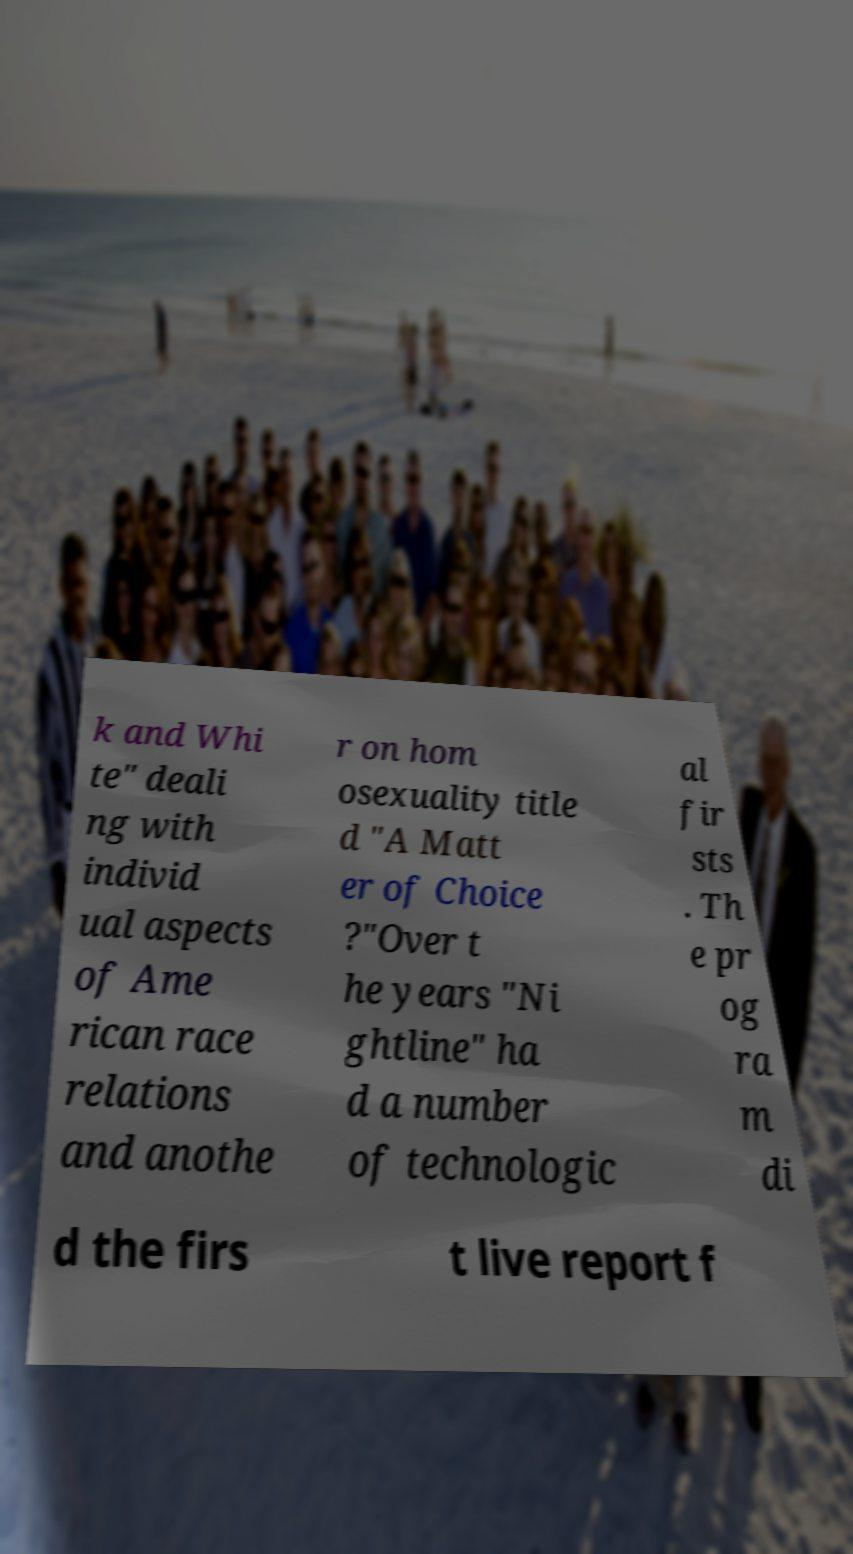For documentation purposes, I need the text within this image transcribed. Could you provide that? k and Whi te" deali ng with individ ual aspects of Ame rican race relations and anothe r on hom osexuality title d "A Matt er of Choice ?"Over t he years "Ni ghtline" ha d a number of technologic al fir sts . Th e pr og ra m di d the firs t live report f 